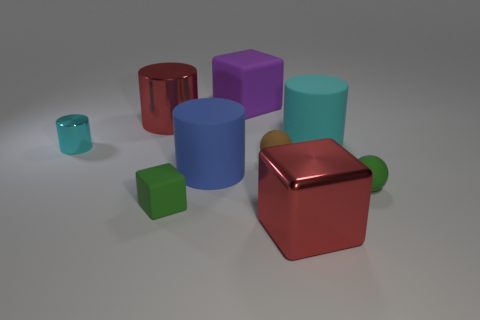Subtract all spheres. How many objects are left? 7 Add 9 big red metal cubes. How many big red metal cubes are left? 10 Add 2 small gray matte cubes. How many small gray matte cubes exist? 2 Subtract 0 gray balls. How many objects are left? 9 Subtract all purple cylinders. Subtract all big cyan things. How many objects are left? 8 